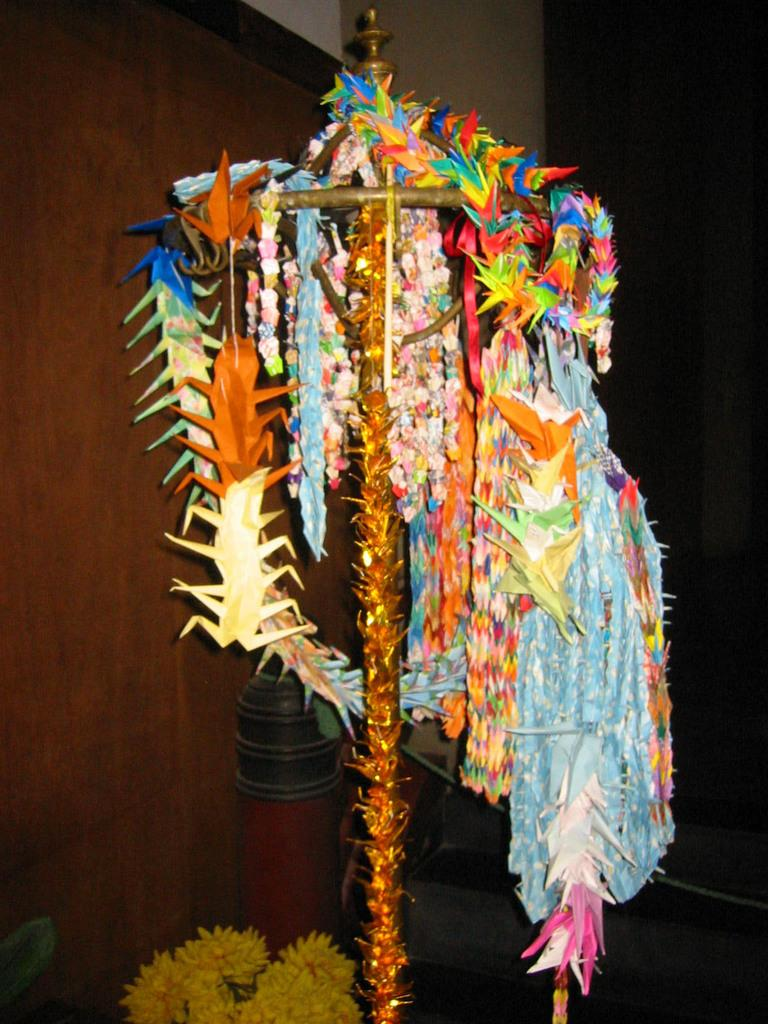What types of objects can be seen in the image? There are decorative objects in the image. Can you describe the background of the image? The background of the image is dark. What type of legal advice is the lawyer providing in the image? There is no lawyer present in the image, so it is not possible to determine what legal advice might be provided. 